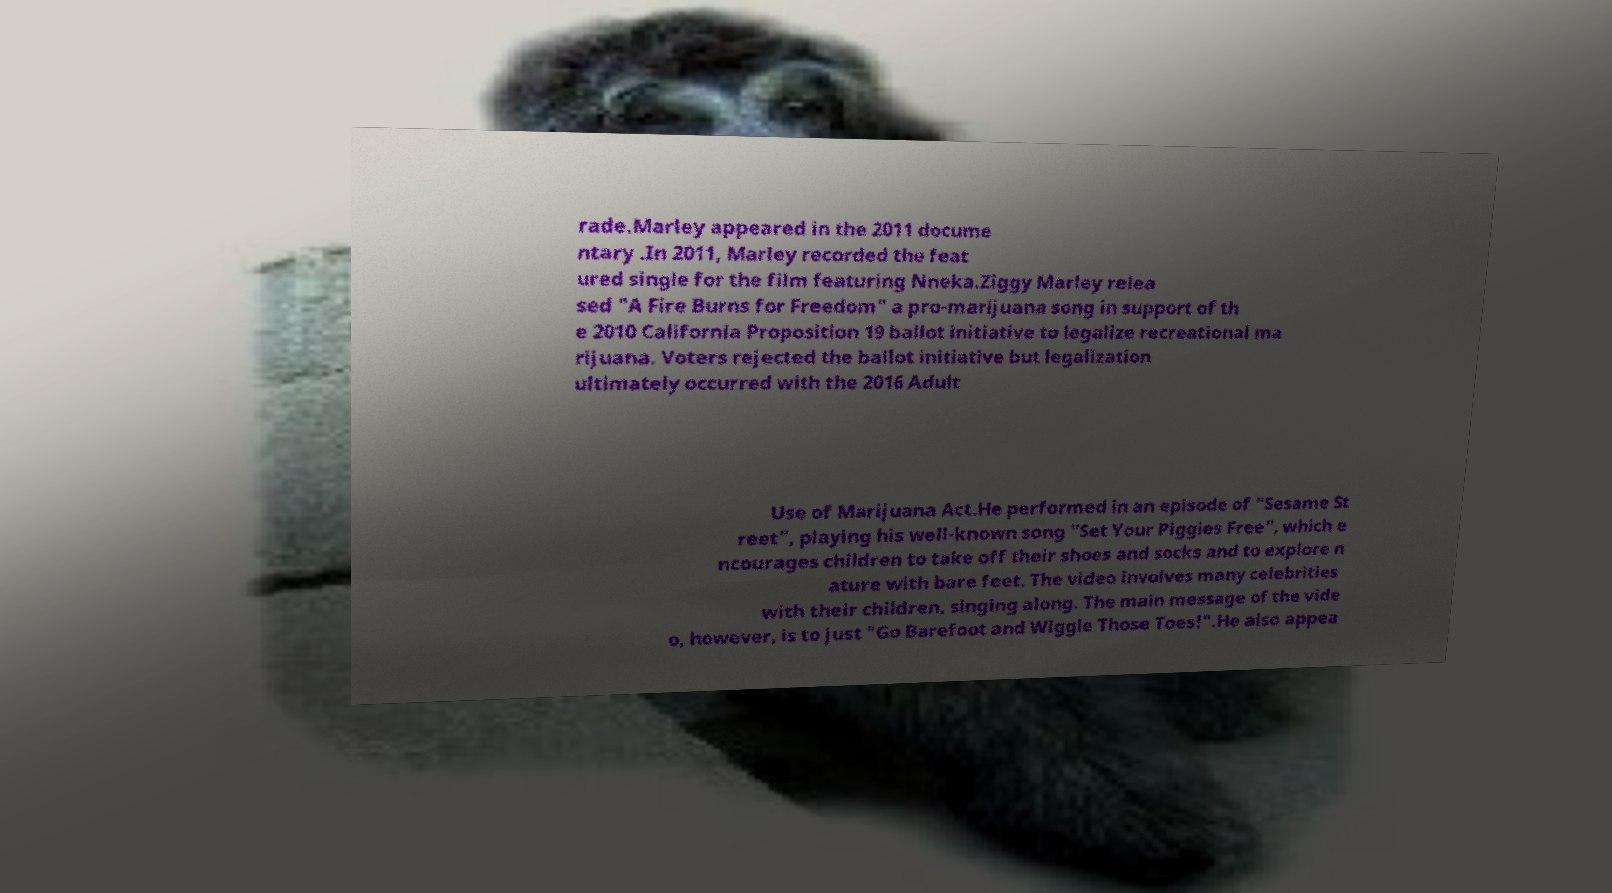What messages or text are displayed in this image? I need them in a readable, typed format. rade.Marley appeared in the 2011 docume ntary .In 2011, Marley recorded the feat ured single for the film featuring Nneka.Ziggy Marley relea sed "A Fire Burns for Freedom" a pro-marijuana song in support of th e 2010 California Proposition 19 ballot initiative to legalize recreational ma rijuana. Voters rejected the ballot initiative but legalization ultimately occurred with the 2016 Adult Use of Marijuana Act.He performed in an episode of "Sesame St reet", playing his well-known song "Set Your Piggies Free", which e ncourages children to take off their shoes and socks and to explore n ature with bare feet. The video involves many celebrities with their children, singing along. The main message of the vide o, however, is to just "Go Barefoot and Wiggle Those Toes!".He also appea 